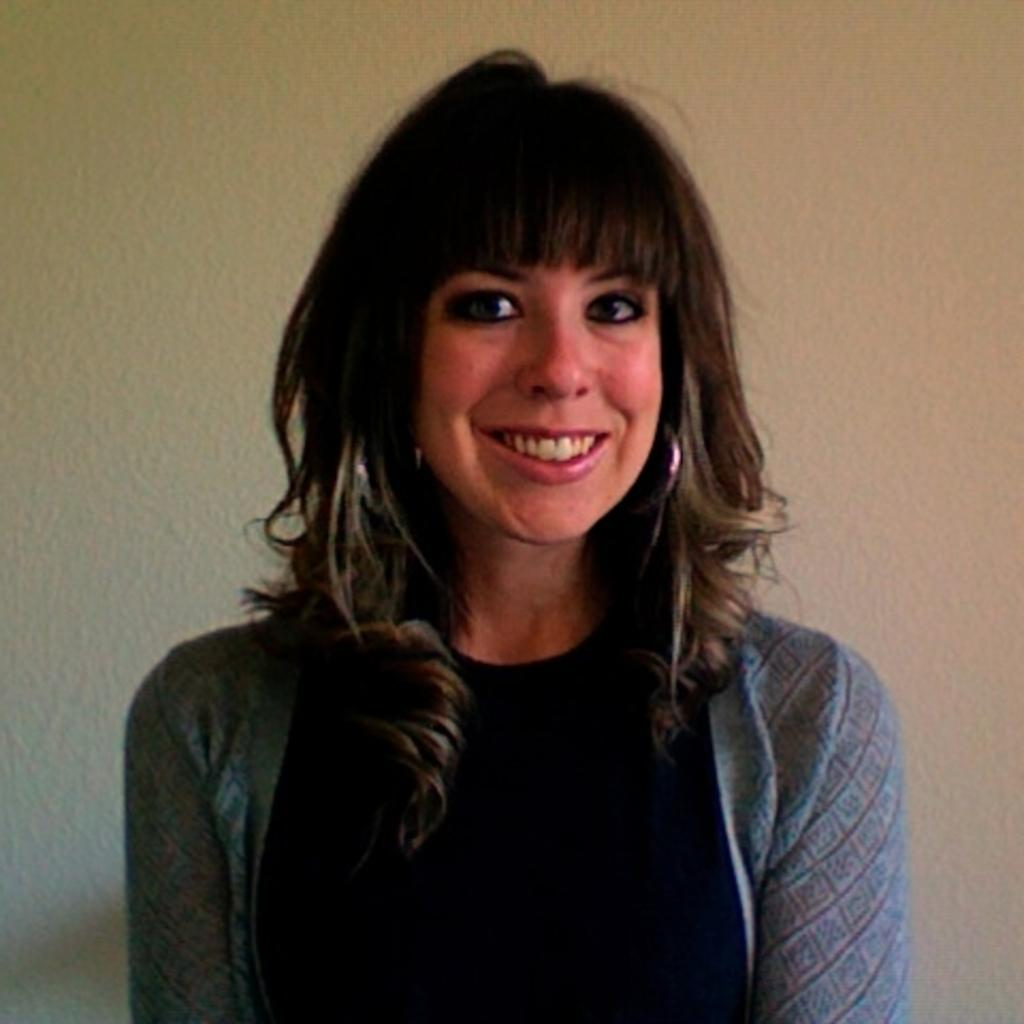Who is the main subject in the image? There is a lady in the center of the image. What is the lady doing in the image? The lady is standing in the image. What is the lady wearing in the image? The lady is wearing a dress in the image. What expression does the lady have in the image? The lady is smiling in the image. What can be seen in the background of the image? There is a wall in the background of the image. What type of food is the lady cooking in the image? There is no indication in the image that the lady is cooking any food, so it cannot be determined from the picture. 